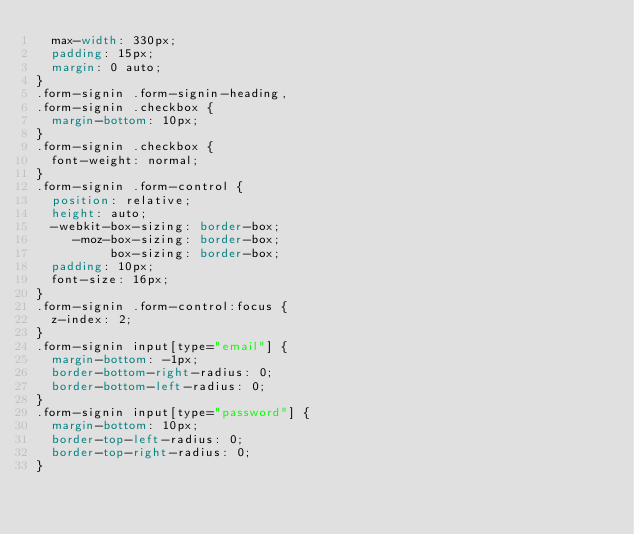<code> <loc_0><loc_0><loc_500><loc_500><_CSS_>  max-width: 330px;
  padding: 15px;
  margin: 0 auto;
}
.form-signin .form-signin-heading,
.form-signin .checkbox {
  margin-bottom: 10px;
}
.form-signin .checkbox {
  font-weight: normal;
}
.form-signin .form-control {
  position: relative;
  height: auto;
  -webkit-box-sizing: border-box;
     -moz-box-sizing: border-box;
          box-sizing: border-box;
  padding: 10px;
  font-size: 16px;
}
.form-signin .form-control:focus {
  z-index: 2;
}
.form-signin input[type="email"] {
  margin-bottom: -1px;
  border-bottom-right-radius: 0;
  border-bottom-left-radius: 0;
}
.form-signin input[type="password"] {
  margin-bottom: 10px;
  border-top-left-radius: 0;
  border-top-right-radius: 0;
}</code> 